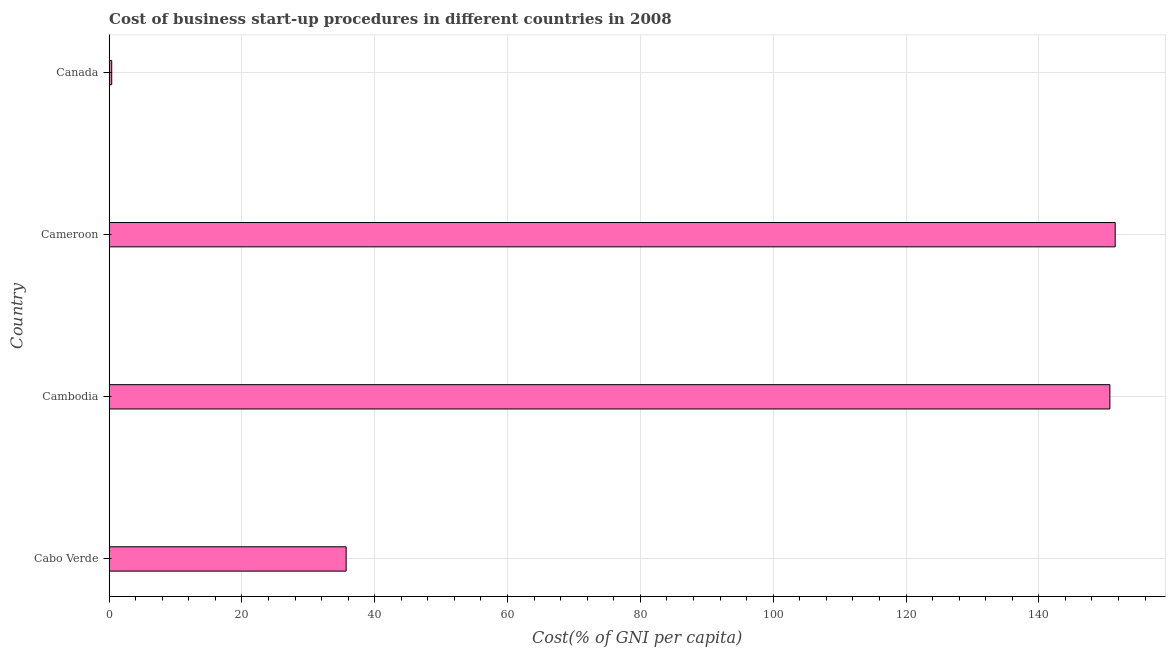What is the title of the graph?
Your response must be concise. Cost of business start-up procedures in different countries in 2008. What is the label or title of the X-axis?
Provide a succinct answer. Cost(% of GNI per capita). What is the label or title of the Y-axis?
Your answer should be compact. Country. What is the cost of business startup procedures in Cameroon?
Your response must be concise. 151.5. Across all countries, what is the maximum cost of business startup procedures?
Ensure brevity in your answer.  151.5. In which country was the cost of business startup procedures maximum?
Your response must be concise. Cameroon. In which country was the cost of business startup procedures minimum?
Your response must be concise. Canada. What is the sum of the cost of business startup procedures?
Ensure brevity in your answer.  338.3. What is the difference between the cost of business startup procedures in Cambodia and Canada?
Give a very brief answer. 150.3. What is the average cost of business startup procedures per country?
Give a very brief answer. 84.58. What is the median cost of business startup procedures?
Your answer should be very brief. 93.2. In how many countries, is the cost of business startup procedures greater than 80 %?
Your answer should be compact. 2. What is the ratio of the cost of business startup procedures in Cabo Verde to that in Cambodia?
Your answer should be very brief. 0.24. Is the cost of business startup procedures in Cabo Verde less than that in Canada?
Make the answer very short. No. Is the difference between the cost of business startup procedures in Cambodia and Cameroon greater than the difference between any two countries?
Provide a short and direct response. No. What is the difference between the highest and the second highest cost of business startup procedures?
Your response must be concise. 0.8. Is the sum of the cost of business startup procedures in Cabo Verde and Cameroon greater than the maximum cost of business startup procedures across all countries?
Offer a very short reply. Yes. What is the difference between the highest and the lowest cost of business startup procedures?
Provide a short and direct response. 151.1. How many bars are there?
Offer a terse response. 4. How many countries are there in the graph?
Keep it short and to the point. 4. What is the difference between two consecutive major ticks on the X-axis?
Your response must be concise. 20. Are the values on the major ticks of X-axis written in scientific E-notation?
Keep it short and to the point. No. What is the Cost(% of GNI per capita) in Cabo Verde?
Offer a terse response. 35.7. What is the Cost(% of GNI per capita) of Cambodia?
Provide a succinct answer. 150.7. What is the Cost(% of GNI per capita) of Cameroon?
Your answer should be compact. 151.5. What is the difference between the Cost(% of GNI per capita) in Cabo Verde and Cambodia?
Offer a terse response. -115. What is the difference between the Cost(% of GNI per capita) in Cabo Verde and Cameroon?
Make the answer very short. -115.8. What is the difference between the Cost(% of GNI per capita) in Cabo Verde and Canada?
Offer a terse response. 35.3. What is the difference between the Cost(% of GNI per capita) in Cambodia and Canada?
Ensure brevity in your answer.  150.3. What is the difference between the Cost(% of GNI per capita) in Cameroon and Canada?
Your answer should be compact. 151.1. What is the ratio of the Cost(% of GNI per capita) in Cabo Verde to that in Cambodia?
Your response must be concise. 0.24. What is the ratio of the Cost(% of GNI per capita) in Cabo Verde to that in Cameroon?
Offer a terse response. 0.24. What is the ratio of the Cost(% of GNI per capita) in Cabo Verde to that in Canada?
Ensure brevity in your answer.  89.25. What is the ratio of the Cost(% of GNI per capita) in Cambodia to that in Canada?
Your answer should be very brief. 376.75. What is the ratio of the Cost(% of GNI per capita) in Cameroon to that in Canada?
Your answer should be very brief. 378.75. 